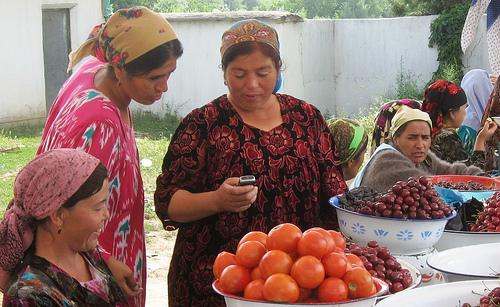The largest food item on any of these tables is found in what sauce? Please explain your reasoning. ketchup. Tomatoes make ketchup and other items. 